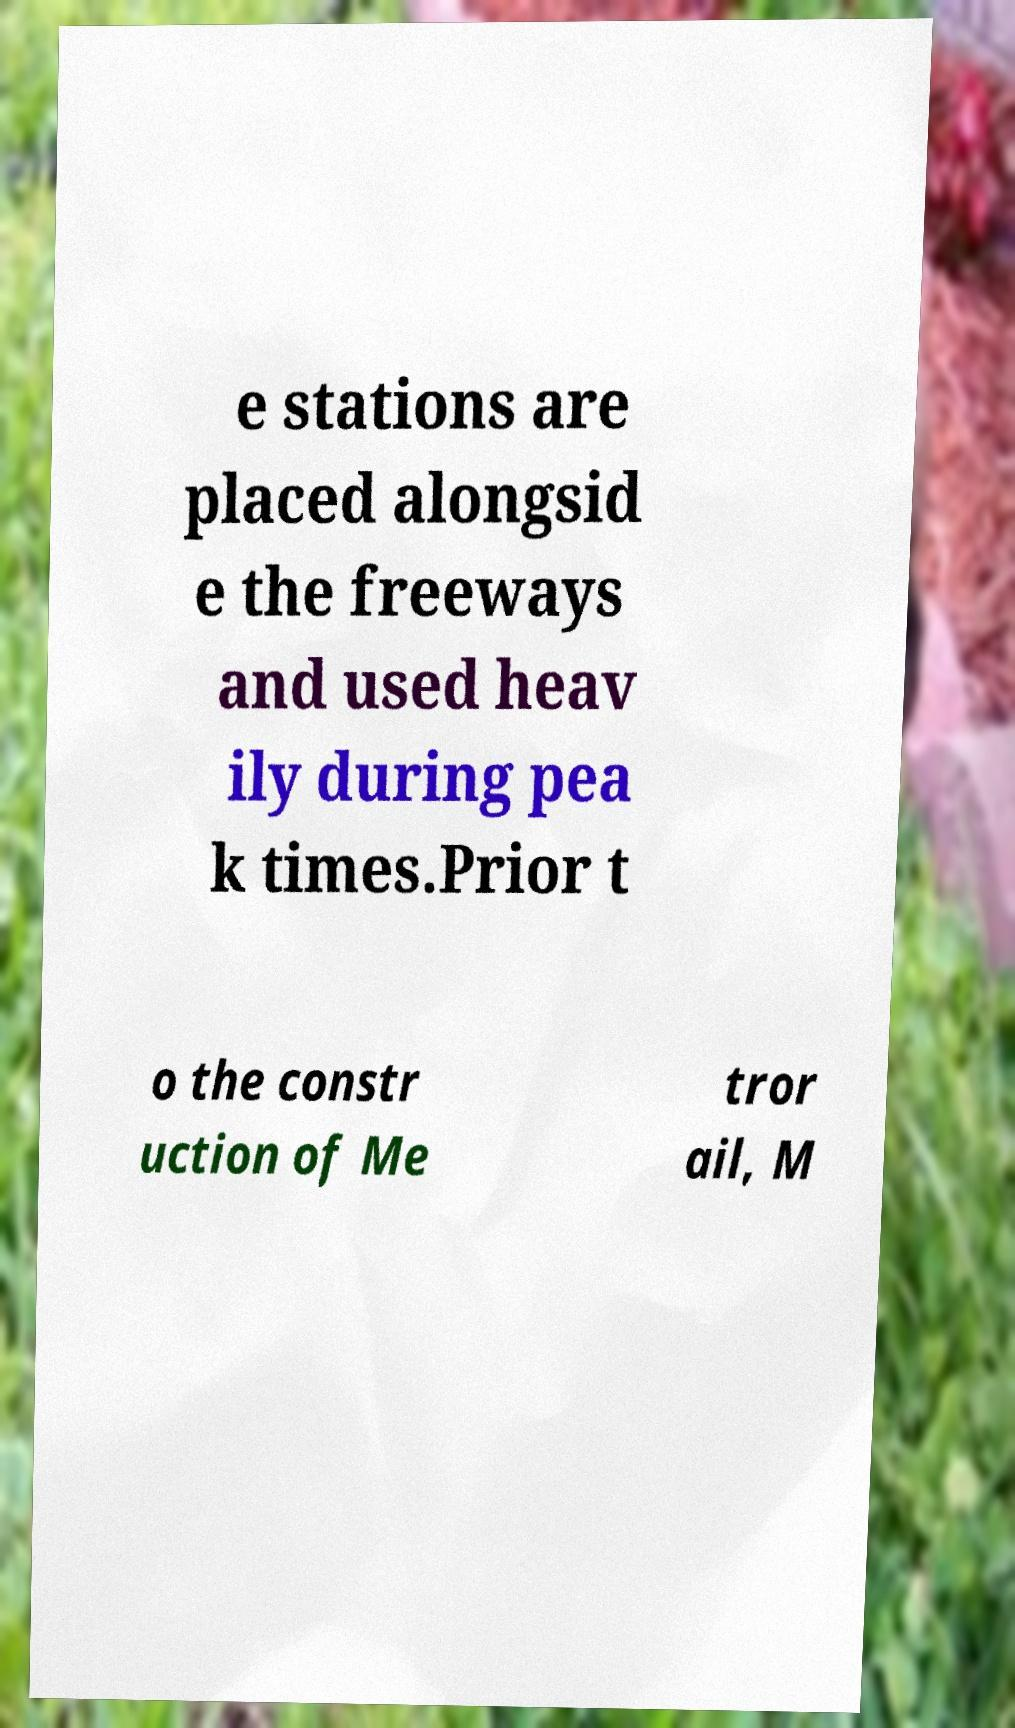Could you assist in decoding the text presented in this image and type it out clearly? e stations are placed alongsid e the freeways and used heav ily during pea k times.Prior t o the constr uction of Me tror ail, M 